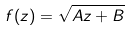<formula> <loc_0><loc_0><loc_500><loc_500>f ( z ) = \sqrt { A z + B }</formula> 